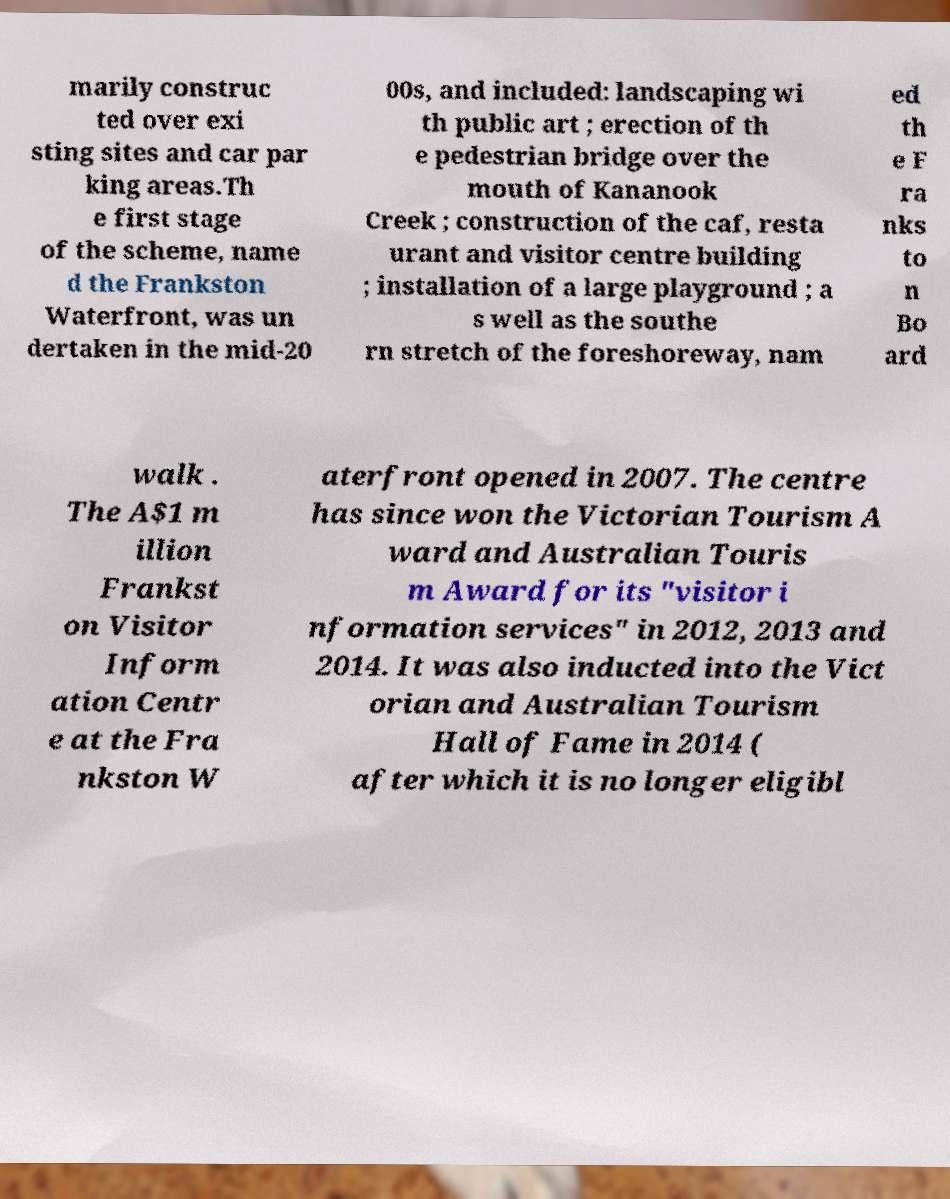Could you assist in decoding the text presented in this image and type it out clearly? marily construc ted over exi sting sites and car par king areas.Th e first stage of the scheme, name d the Frankston Waterfront, was un dertaken in the mid-20 00s, and included: landscaping wi th public art ; erection of th e pedestrian bridge over the mouth of Kananook Creek ; construction of the caf, resta urant and visitor centre building ; installation of a large playground ; a s well as the southe rn stretch of the foreshoreway, nam ed th e F ra nks to n Bo ard walk . The A$1 m illion Frankst on Visitor Inform ation Centr e at the Fra nkston W aterfront opened in 2007. The centre has since won the Victorian Tourism A ward and Australian Touris m Award for its "visitor i nformation services" in 2012, 2013 and 2014. It was also inducted into the Vict orian and Australian Tourism Hall of Fame in 2014 ( after which it is no longer eligibl 